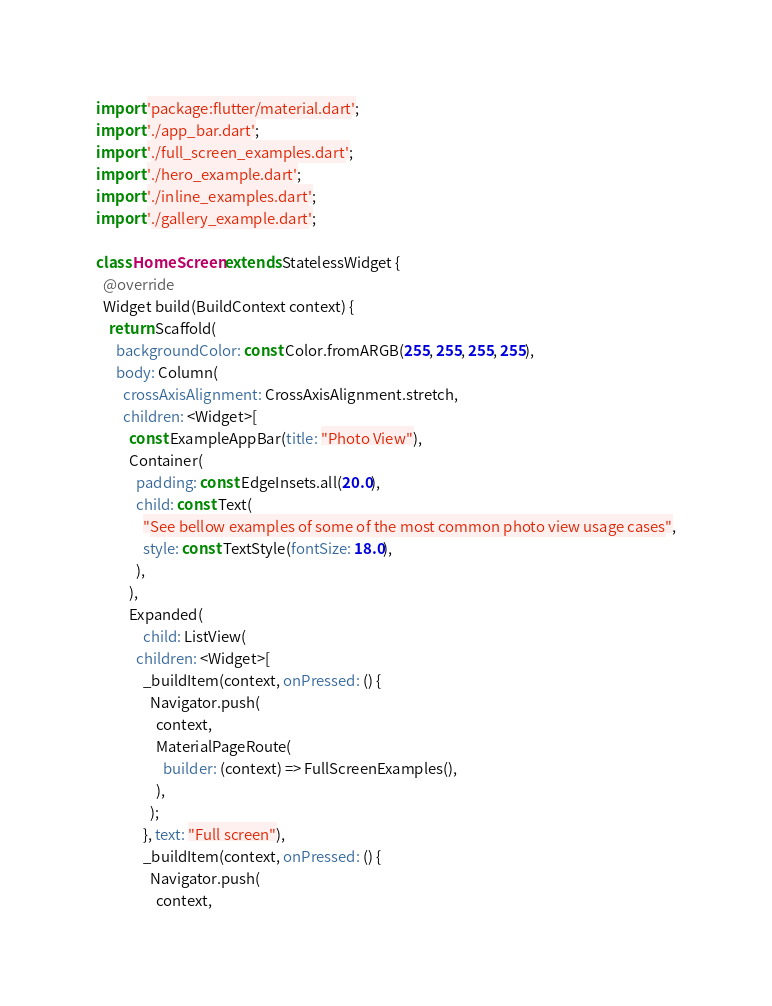Convert code to text. <code><loc_0><loc_0><loc_500><loc_500><_Dart_>import 'package:flutter/material.dart';
import './app_bar.dart';
import './full_screen_examples.dart';
import './hero_example.dart';
import './inline_examples.dart';
import './gallery_example.dart';

class HomeScreen extends StatelessWidget {
  @override
  Widget build(BuildContext context) {
    return Scaffold(
      backgroundColor: const Color.fromARGB(255, 255, 255, 255),
      body: Column(
        crossAxisAlignment: CrossAxisAlignment.stretch,
        children: <Widget>[
          const ExampleAppBar(title: "Photo View"),
          Container(
            padding: const EdgeInsets.all(20.0),
            child: const Text(
              "See bellow examples of some of the most common photo view usage cases",
              style: const TextStyle(fontSize: 18.0),
            ),
          ),
          Expanded(
              child: ListView(
            children: <Widget>[
              _buildItem(context, onPressed: () {
                Navigator.push(
                  context,
                  MaterialPageRoute(
                    builder: (context) => FullScreenExamples(),
                  ),
                );
              }, text: "Full screen"),
              _buildItem(context, onPressed: () {
                Navigator.push(
                  context,</code> 